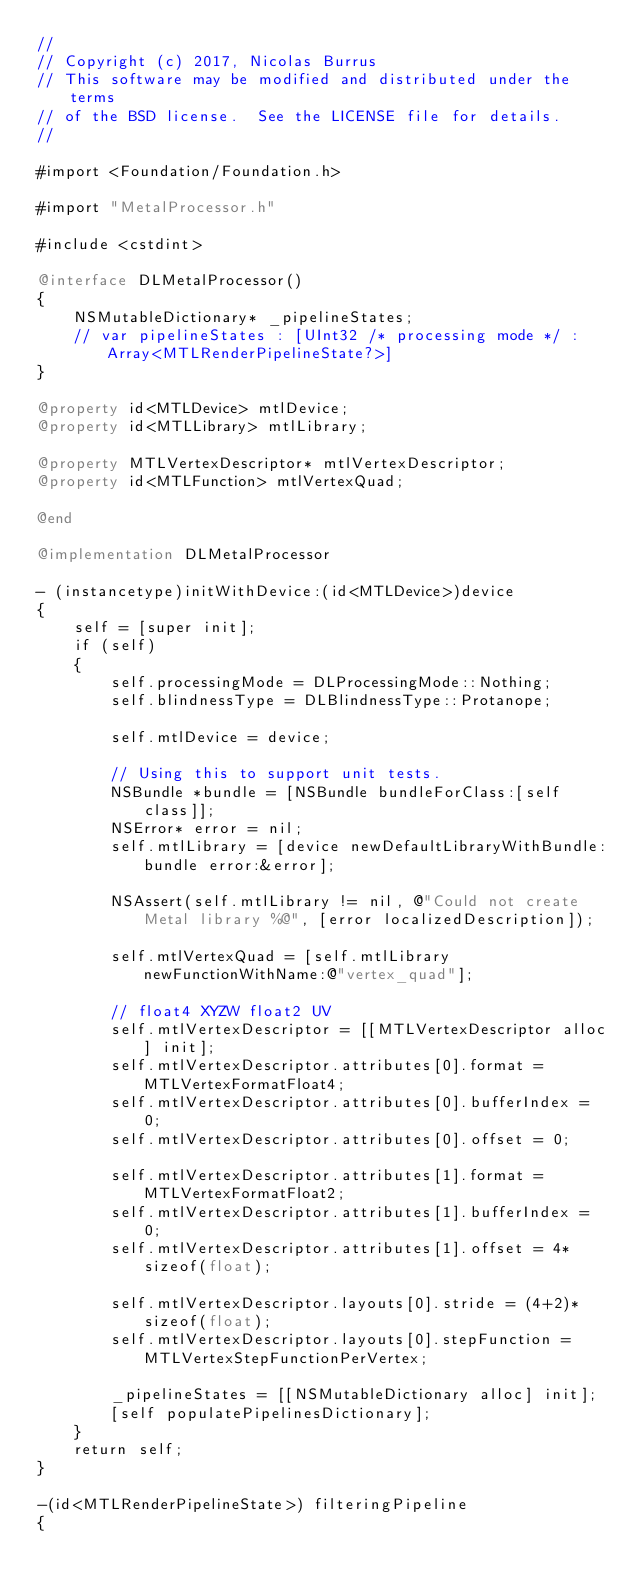Convert code to text. <code><loc_0><loc_0><loc_500><loc_500><_ObjectiveC_>//
// Copyright (c) 2017, Nicolas Burrus
// This software may be modified and distributed under the terms
// of the BSD license.  See the LICENSE file for details.
//

#import <Foundation/Foundation.h>

#import "MetalProcessor.h"

#include <cstdint>

@interface DLMetalProcessor()
{
    NSMutableDictionary* _pipelineStates;
    // var pipelineStates : [UInt32 /* processing mode */ : Array<MTLRenderPipelineState?>]
}

@property id<MTLDevice> mtlDevice;
@property id<MTLLibrary> mtlLibrary;

@property MTLVertexDescriptor* mtlVertexDescriptor;
@property id<MTLFunction> mtlVertexQuad;

@end

@implementation DLMetalProcessor

- (instancetype)initWithDevice:(id<MTLDevice>)device
{
    self = [super init];
    if (self)
    {
        self.processingMode = DLProcessingMode::Nothing;
        self.blindnessType = DLBlindnessType::Protanope;
        
        self.mtlDevice = device;
        
        // Using this to support unit tests.
        NSBundle *bundle = [NSBundle bundleForClass:[self class]];
        NSError* error = nil;
        self.mtlLibrary = [device newDefaultLibraryWithBundle:bundle error:&error];
        
        NSAssert(self.mtlLibrary != nil, @"Could not create Metal library %@", [error localizedDescription]);
        
        self.mtlVertexQuad = [self.mtlLibrary newFunctionWithName:@"vertex_quad"];
        
        // float4 XYZW float2 UV
        self.mtlVertexDescriptor = [[MTLVertexDescriptor alloc] init];
        self.mtlVertexDescriptor.attributes[0].format = MTLVertexFormatFloat4;
        self.mtlVertexDescriptor.attributes[0].bufferIndex = 0;
        self.mtlVertexDescriptor.attributes[0].offset = 0;
        
        self.mtlVertexDescriptor.attributes[1].format = MTLVertexFormatFloat2;
        self.mtlVertexDescriptor.attributes[1].bufferIndex = 0;
        self.mtlVertexDescriptor.attributes[1].offset = 4*sizeof(float);
        
        self.mtlVertexDescriptor.layouts[0].stride = (4+2)*sizeof(float);
        self.mtlVertexDescriptor.layouts[0].stepFunction = MTLVertexStepFunctionPerVertex;
        
        _pipelineStates = [[NSMutableDictionary alloc] init];
        [self populatePipelinesDictionary];
    }
    return self;
}

-(id<MTLRenderPipelineState>) filteringPipeline
{</code> 